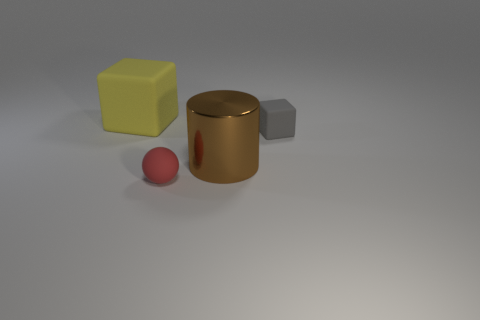Add 2 small red things. How many objects exist? 6 Subtract all balls. How many objects are left? 3 Add 4 gray cubes. How many gray cubes exist? 5 Subtract 0 green balls. How many objects are left? 4 Subtract all red rubber blocks. Subtract all small rubber things. How many objects are left? 2 Add 3 large brown metal objects. How many large brown metal objects are left? 4 